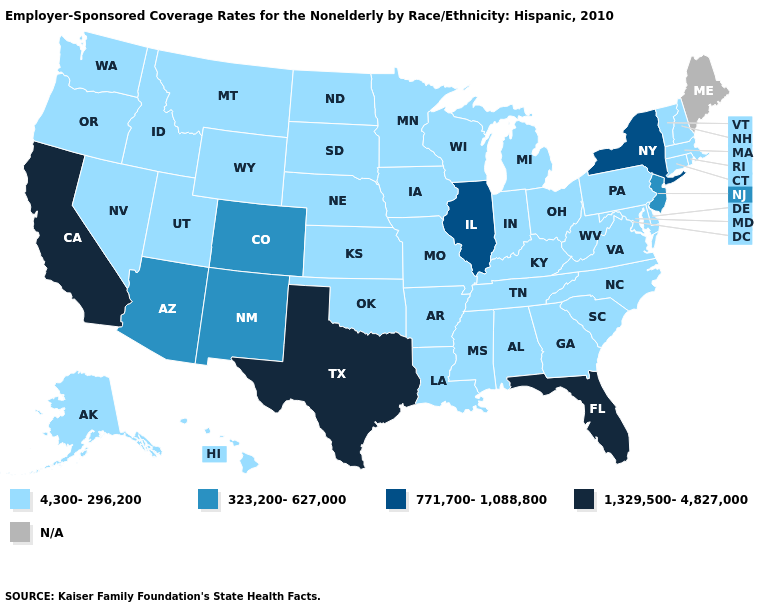What is the lowest value in states that border Michigan?
Give a very brief answer. 4,300-296,200. Does the first symbol in the legend represent the smallest category?
Be succinct. Yes. Among the states that border Rhode Island , which have the highest value?
Short answer required. Connecticut, Massachusetts. What is the value of Mississippi?
Short answer required. 4,300-296,200. Name the states that have a value in the range 4,300-296,200?
Short answer required. Alabama, Alaska, Arkansas, Connecticut, Delaware, Georgia, Hawaii, Idaho, Indiana, Iowa, Kansas, Kentucky, Louisiana, Maryland, Massachusetts, Michigan, Minnesota, Mississippi, Missouri, Montana, Nebraska, Nevada, New Hampshire, North Carolina, North Dakota, Ohio, Oklahoma, Oregon, Pennsylvania, Rhode Island, South Carolina, South Dakota, Tennessee, Utah, Vermont, Virginia, Washington, West Virginia, Wisconsin, Wyoming. What is the value of Massachusetts?
Quick response, please. 4,300-296,200. Does Florida have the highest value in the USA?
Quick response, please. Yes. Which states hav the highest value in the MidWest?
Answer briefly. Illinois. Name the states that have a value in the range N/A?
Give a very brief answer. Maine. What is the value of Montana?
Quick response, please. 4,300-296,200. Name the states that have a value in the range 1,329,500-4,827,000?
Answer briefly. California, Florida, Texas. Name the states that have a value in the range 771,700-1,088,800?
Answer briefly. Illinois, New York. 